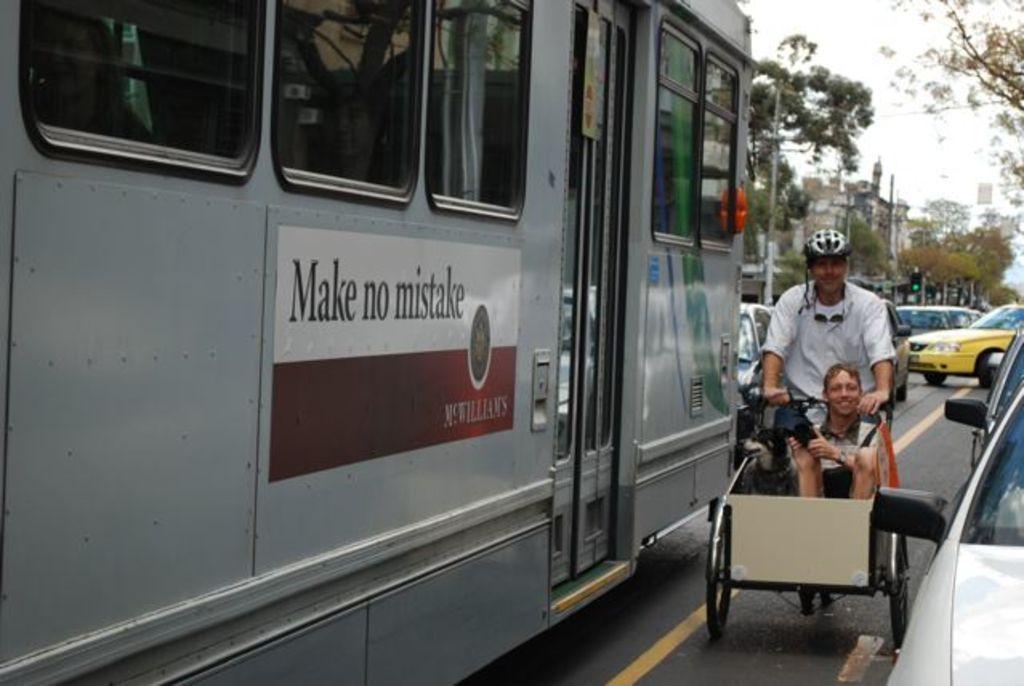Please provide a concise description of this image. In this image I see number of vehicles and I see 2 men and a dog on this thing and I see the road on which there is an yellow line and I see few words written and I see a logo over here. In the background I see the trees, buildings and the sky. 